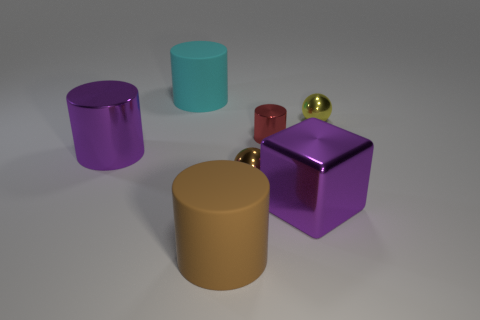What number of other objects are there of the same shape as the large brown thing?
Offer a very short reply. 3. There is a purple thing left of the small red cylinder; what shape is it?
Your response must be concise. Cylinder. There is a big brown matte thing on the left side of the yellow metal sphere; is it the same shape as the thing that is on the right side of the big block?
Make the answer very short. No. Are there an equal number of brown rubber things that are left of the small yellow metal thing and small brown balls?
Provide a succinct answer. Yes. What material is the other object that is the same shape as the tiny yellow metallic object?
Your answer should be very brief. Metal. The large purple shiny object in front of the small shiny ball to the left of the purple cube is what shape?
Your answer should be very brief. Cube. Are the yellow thing on the right side of the brown cylinder and the large brown object made of the same material?
Ensure brevity in your answer.  No. Is the number of big things that are behind the tiny yellow ball the same as the number of big shiny things that are to the right of the large metal cylinder?
Make the answer very short. Yes. What material is the large thing that is the same color as the block?
Your response must be concise. Metal. There is a purple shiny object right of the red shiny cylinder; how many big purple shiny objects are on the left side of it?
Keep it short and to the point. 1. 